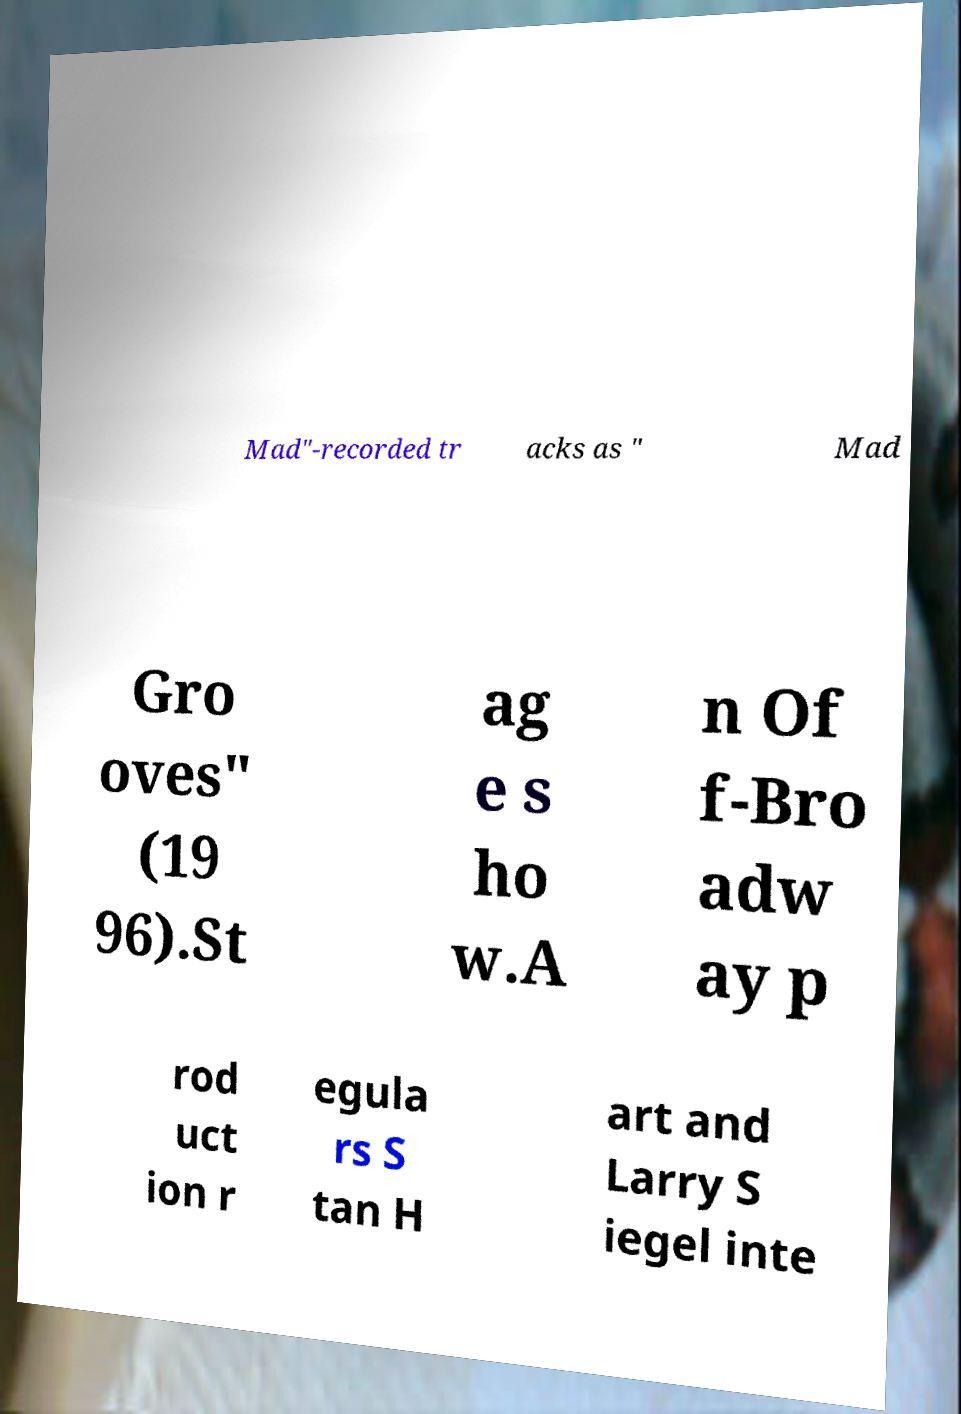What messages or text are displayed in this image? I need them in a readable, typed format. Mad"-recorded tr acks as " Mad Gro oves" (19 96).St ag e s ho w.A n Of f-Bro adw ay p rod uct ion r egula rs S tan H art and Larry S iegel inte 